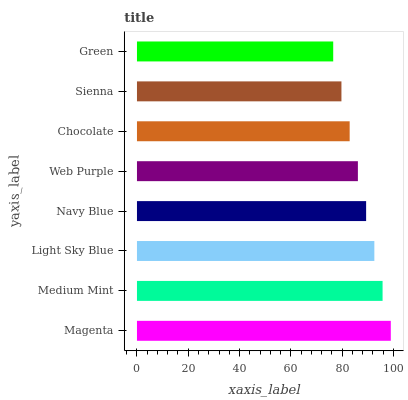Is Green the minimum?
Answer yes or no. Yes. Is Magenta the maximum?
Answer yes or no. Yes. Is Medium Mint the minimum?
Answer yes or no. No. Is Medium Mint the maximum?
Answer yes or no. No. Is Magenta greater than Medium Mint?
Answer yes or no. Yes. Is Medium Mint less than Magenta?
Answer yes or no. Yes. Is Medium Mint greater than Magenta?
Answer yes or no. No. Is Magenta less than Medium Mint?
Answer yes or no. No. Is Navy Blue the high median?
Answer yes or no. Yes. Is Web Purple the low median?
Answer yes or no. Yes. Is Light Sky Blue the high median?
Answer yes or no. No. Is Light Sky Blue the low median?
Answer yes or no. No. 